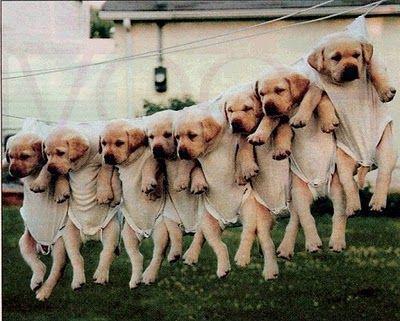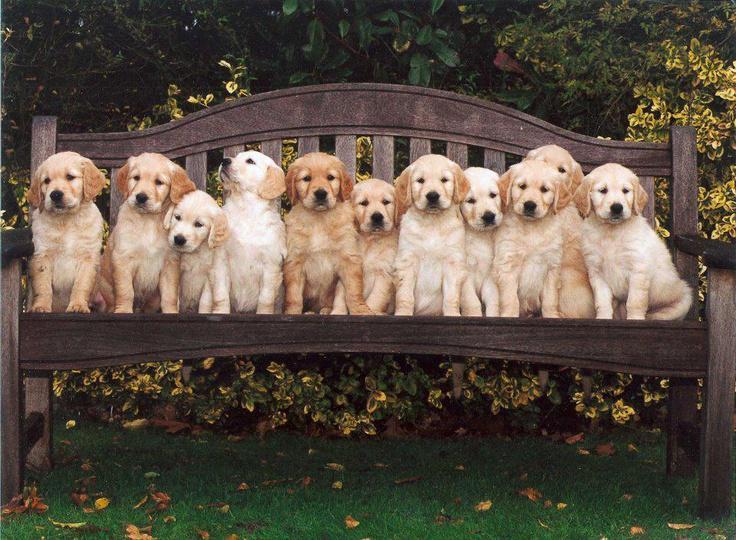The first image is the image on the left, the second image is the image on the right. Analyze the images presented: Is the assertion "An image includes a hunting dog and a captured prey bird." valid? Answer yes or no. No. The first image is the image on the left, the second image is the image on the right. Assess this claim about the two images: "More than half a dozen dogs are lined up in each image.". Correct or not? Answer yes or no. Yes. 